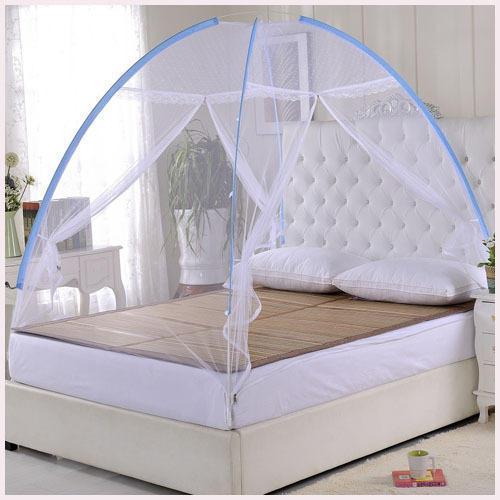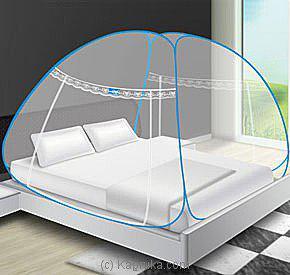The first image is the image on the left, the second image is the image on the right. Evaluate the accuracy of this statement regarding the images: "Each image shows a bed with a dome-shaped canopy over its mattress like a tent, and at least one canopy has blue edges.". Is it true? Answer yes or no. Yes. The first image is the image on the left, the second image is the image on the right. Evaluate the accuracy of this statement regarding the images: "One bed netting is pink.". Is it true? Answer yes or no. No. 